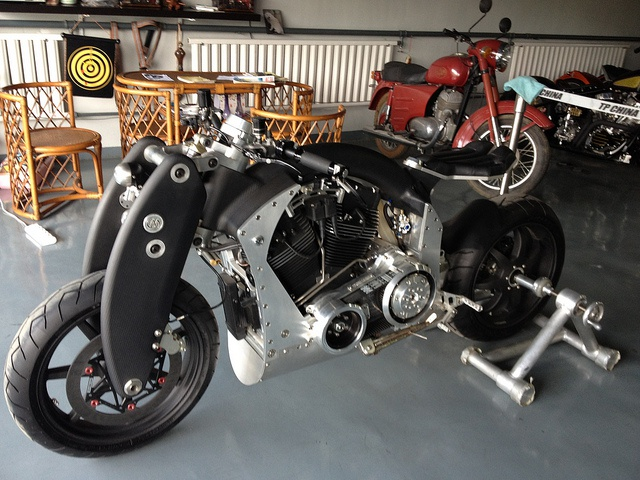Describe the objects in this image and their specific colors. I can see motorcycle in gray, black, darkgray, and white tones, motorcycle in gray, black, maroon, and brown tones, chair in gray, maroon, ivory, and orange tones, motorcycle in gray, black, and olive tones, and chair in gray, orange, maroon, and brown tones in this image. 